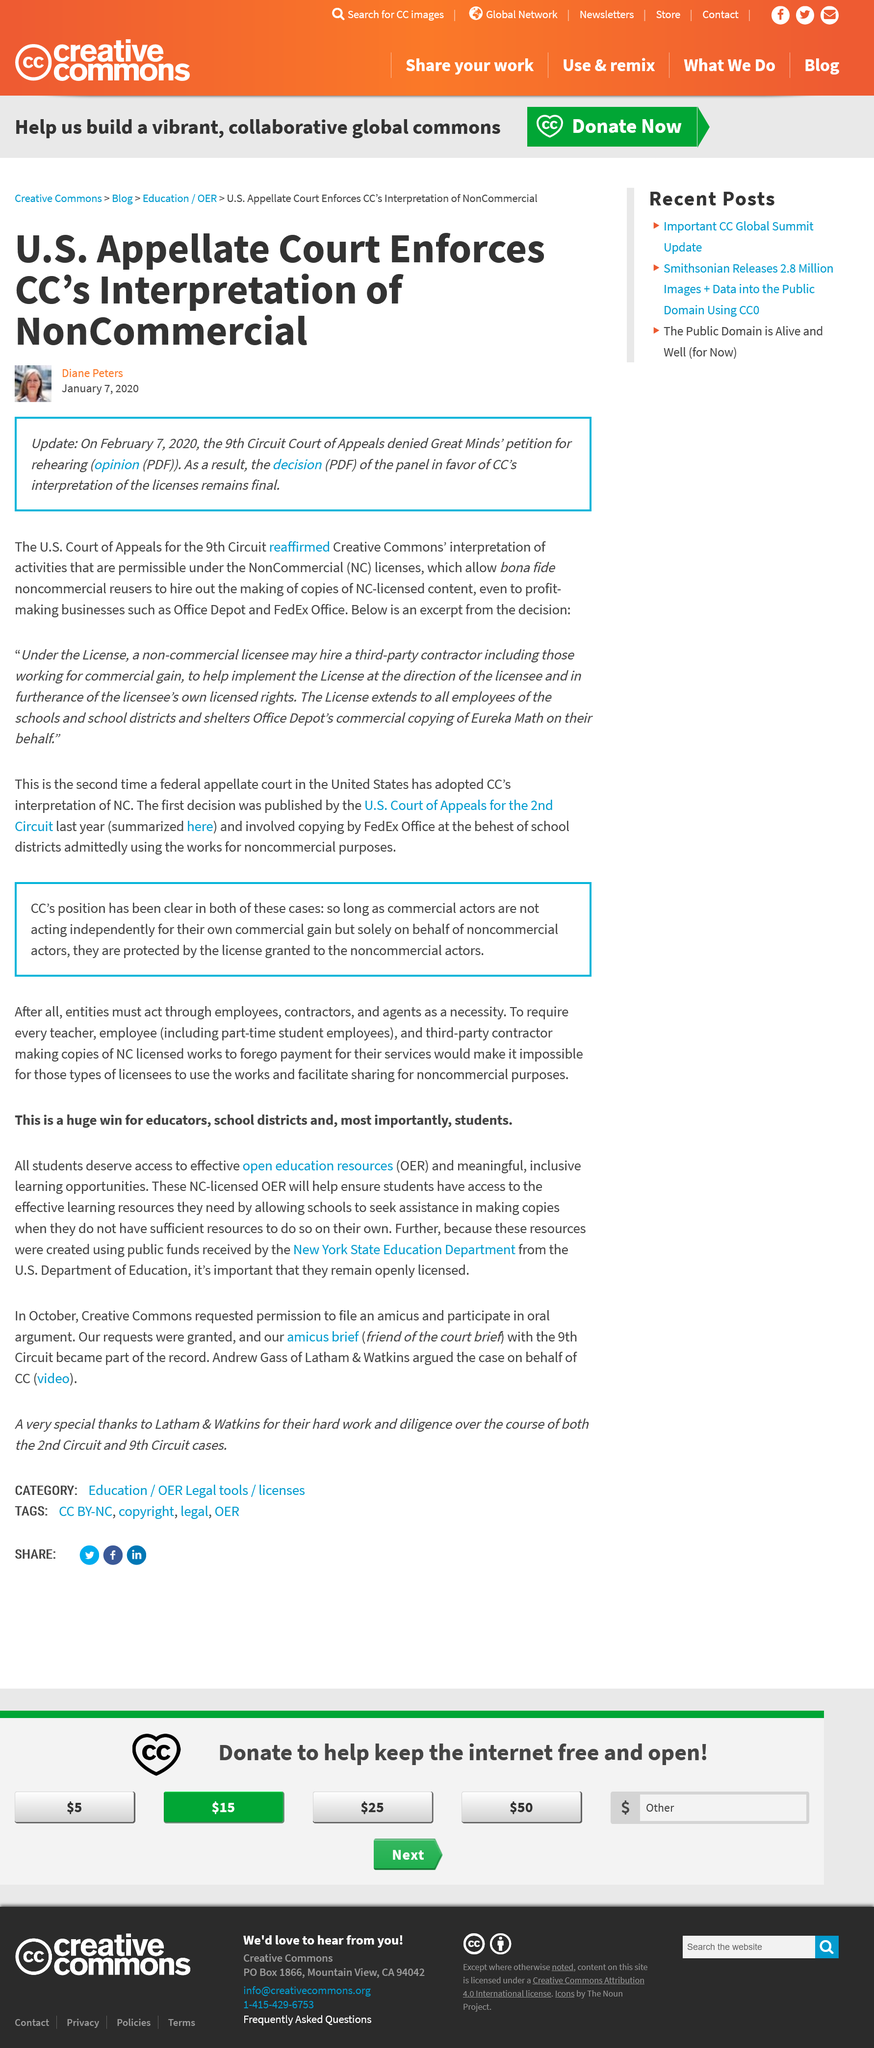Give some essential details in this illustration. The two groups that were in dispute before the court were Great Minds and Creative Commons. The case was not reheard, a rehearing was denied. Two commercial businesses are named as examples: Office Depot and FedEx Office. 